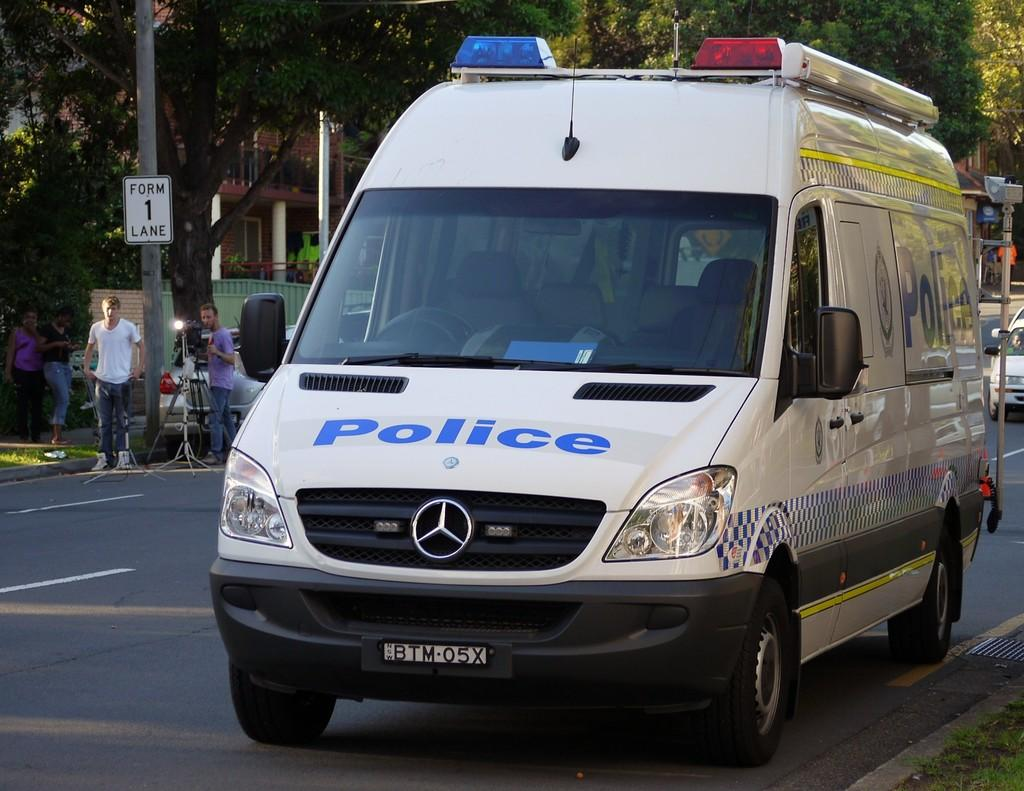<image>
Relay a brief, clear account of the picture shown. A Mercedes van says police with a plate that says BTM05X. 